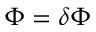Convert formula to latex. <formula><loc_0><loc_0><loc_500><loc_500>\Phi = \delta \Phi</formula> 